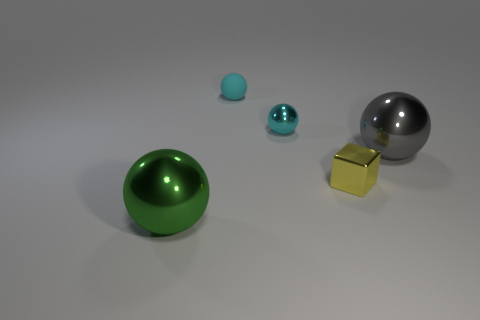Add 3 big cyan cylinders. How many objects exist? 8 Subtract all spheres. How many objects are left? 1 Subtract all large brown objects. Subtract all cyan metallic objects. How many objects are left? 4 Add 5 big objects. How many big objects are left? 7 Add 5 large brown things. How many large brown things exist? 5 Subtract 0 cyan cubes. How many objects are left? 5 